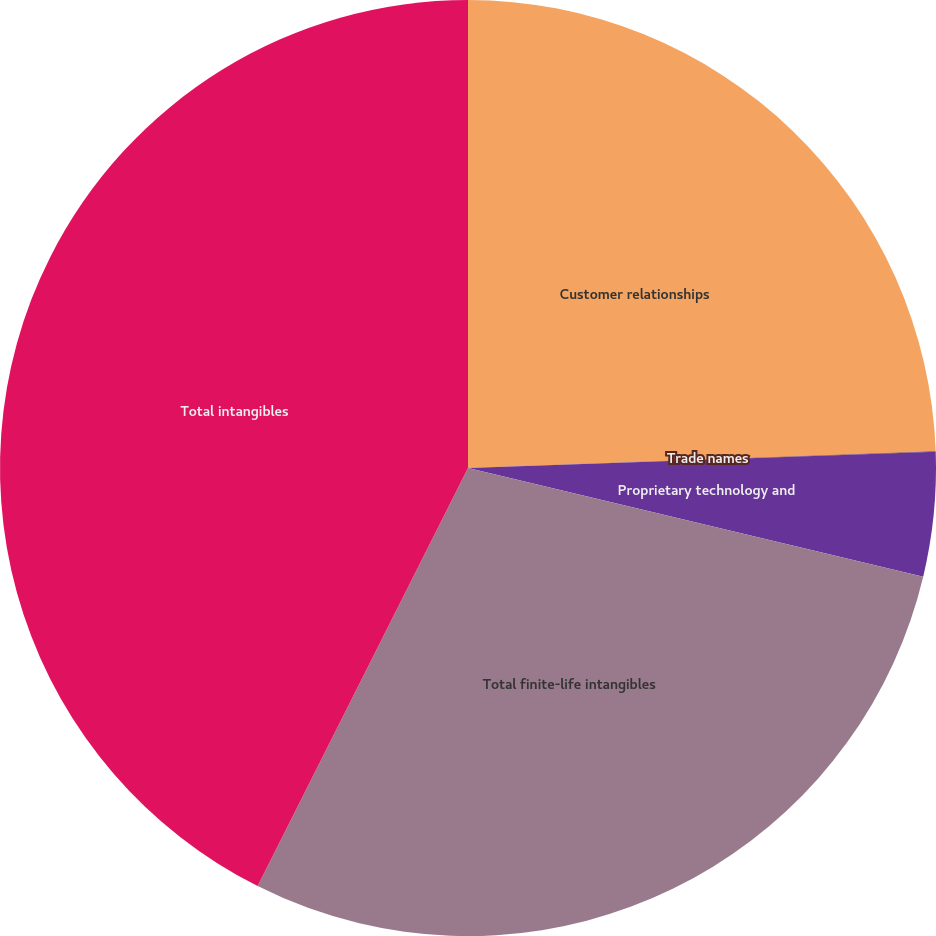Convert chart. <chart><loc_0><loc_0><loc_500><loc_500><pie_chart><fcel>Customer relationships<fcel>Trade names<fcel>Proprietary technology and<fcel>Total finite-life intangibles<fcel>Total intangibles<nl><fcel>24.43%<fcel>0.02%<fcel>4.28%<fcel>28.69%<fcel>42.58%<nl></chart> 